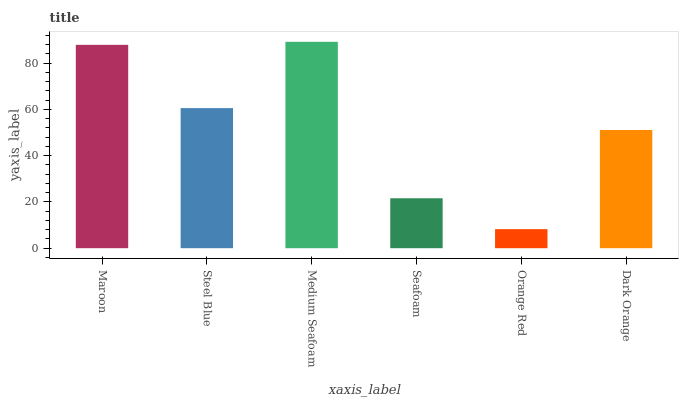Is Orange Red the minimum?
Answer yes or no. Yes. Is Medium Seafoam the maximum?
Answer yes or no. Yes. Is Steel Blue the minimum?
Answer yes or no. No. Is Steel Blue the maximum?
Answer yes or no. No. Is Maroon greater than Steel Blue?
Answer yes or no. Yes. Is Steel Blue less than Maroon?
Answer yes or no. Yes. Is Steel Blue greater than Maroon?
Answer yes or no. No. Is Maroon less than Steel Blue?
Answer yes or no. No. Is Steel Blue the high median?
Answer yes or no. Yes. Is Dark Orange the low median?
Answer yes or no. Yes. Is Maroon the high median?
Answer yes or no. No. Is Medium Seafoam the low median?
Answer yes or no. No. 